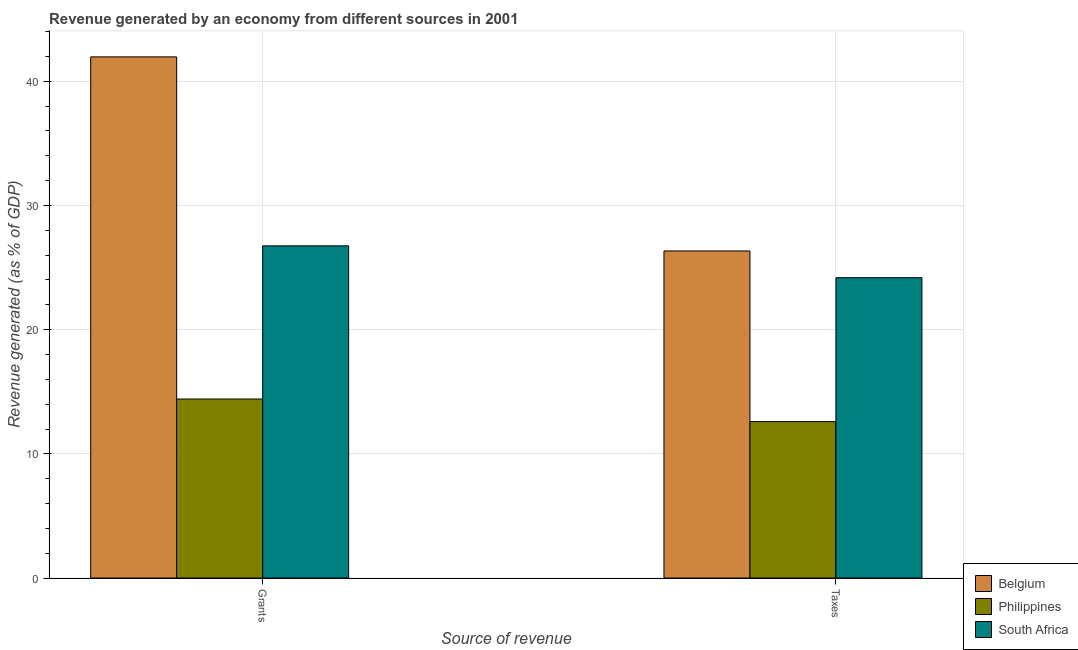How many groups of bars are there?
Provide a succinct answer. 2. Are the number of bars on each tick of the X-axis equal?
Ensure brevity in your answer.  Yes. How many bars are there on the 2nd tick from the left?
Offer a very short reply. 3. What is the label of the 1st group of bars from the left?
Make the answer very short. Grants. What is the revenue generated by grants in Belgium?
Your answer should be very brief. 41.97. Across all countries, what is the maximum revenue generated by grants?
Provide a succinct answer. 41.97. Across all countries, what is the minimum revenue generated by grants?
Ensure brevity in your answer.  14.41. In which country was the revenue generated by taxes maximum?
Offer a very short reply. Belgium. In which country was the revenue generated by grants minimum?
Provide a short and direct response. Philippines. What is the total revenue generated by grants in the graph?
Keep it short and to the point. 83.13. What is the difference between the revenue generated by grants in Philippines and that in Belgium?
Give a very brief answer. -27.55. What is the difference between the revenue generated by grants in Philippines and the revenue generated by taxes in Belgium?
Give a very brief answer. -11.92. What is the average revenue generated by taxes per country?
Your answer should be compact. 21.04. What is the difference between the revenue generated by grants and revenue generated by taxes in South Africa?
Give a very brief answer. 2.56. What is the ratio of the revenue generated by grants in South Africa to that in Belgium?
Ensure brevity in your answer.  0.64. Is the revenue generated by taxes in South Africa less than that in Belgium?
Make the answer very short. Yes. In how many countries, is the revenue generated by grants greater than the average revenue generated by grants taken over all countries?
Keep it short and to the point. 1. What does the 3rd bar from the left in Grants represents?
Offer a terse response. South Africa. What does the 3rd bar from the right in Taxes represents?
Give a very brief answer. Belgium. How many bars are there?
Your response must be concise. 6. How many countries are there in the graph?
Your answer should be very brief. 3. What is the difference between two consecutive major ticks on the Y-axis?
Give a very brief answer. 10. Does the graph contain any zero values?
Offer a very short reply. No. How many legend labels are there?
Make the answer very short. 3. How are the legend labels stacked?
Your answer should be very brief. Vertical. What is the title of the graph?
Keep it short and to the point. Revenue generated by an economy from different sources in 2001. What is the label or title of the X-axis?
Offer a very short reply. Source of revenue. What is the label or title of the Y-axis?
Ensure brevity in your answer.  Revenue generated (as % of GDP). What is the Revenue generated (as % of GDP) of Belgium in Grants?
Your answer should be compact. 41.97. What is the Revenue generated (as % of GDP) of Philippines in Grants?
Offer a very short reply. 14.41. What is the Revenue generated (as % of GDP) of South Africa in Grants?
Provide a succinct answer. 26.75. What is the Revenue generated (as % of GDP) in Belgium in Taxes?
Your answer should be very brief. 26.34. What is the Revenue generated (as % of GDP) of Philippines in Taxes?
Ensure brevity in your answer.  12.6. What is the Revenue generated (as % of GDP) of South Africa in Taxes?
Give a very brief answer. 24.19. Across all Source of revenue, what is the maximum Revenue generated (as % of GDP) of Belgium?
Offer a terse response. 41.97. Across all Source of revenue, what is the maximum Revenue generated (as % of GDP) in Philippines?
Your answer should be very brief. 14.41. Across all Source of revenue, what is the maximum Revenue generated (as % of GDP) of South Africa?
Make the answer very short. 26.75. Across all Source of revenue, what is the minimum Revenue generated (as % of GDP) of Belgium?
Ensure brevity in your answer.  26.34. Across all Source of revenue, what is the minimum Revenue generated (as % of GDP) in Philippines?
Give a very brief answer. 12.6. Across all Source of revenue, what is the minimum Revenue generated (as % of GDP) of South Africa?
Your answer should be compact. 24.19. What is the total Revenue generated (as % of GDP) in Belgium in the graph?
Offer a terse response. 68.3. What is the total Revenue generated (as % of GDP) of Philippines in the graph?
Your response must be concise. 27.01. What is the total Revenue generated (as % of GDP) in South Africa in the graph?
Provide a short and direct response. 50.94. What is the difference between the Revenue generated (as % of GDP) in Belgium in Grants and that in Taxes?
Ensure brevity in your answer.  15.63. What is the difference between the Revenue generated (as % of GDP) of Philippines in Grants and that in Taxes?
Keep it short and to the point. 1.82. What is the difference between the Revenue generated (as % of GDP) of South Africa in Grants and that in Taxes?
Your response must be concise. 2.56. What is the difference between the Revenue generated (as % of GDP) in Belgium in Grants and the Revenue generated (as % of GDP) in Philippines in Taxes?
Give a very brief answer. 29.37. What is the difference between the Revenue generated (as % of GDP) in Belgium in Grants and the Revenue generated (as % of GDP) in South Africa in Taxes?
Ensure brevity in your answer.  17.78. What is the difference between the Revenue generated (as % of GDP) of Philippines in Grants and the Revenue generated (as % of GDP) of South Africa in Taxes?
Offer a terse response. -9.77. What is the average Revenue generated (as % of GDP) of Belgium per Source of revenue?
Make the answer very short. 34.15. What is the average Revenue generated (as % of GDP) in Philippines per Source of revenue?
Provide a succinct answer. 13.51. What is the average Revenue generated (as % of GDP) of South Africa per Source of revenue?
Ensure brevity in your answer.  25.47. What is the difference between the Revenue generated (as % of GDP) in Belgium and Revenue generated (as % of GDP) in Philippines in Grants?
Make the answer very short. 27.55. What is the difference between the Revenue generated (as % of GDP) of Belgium and Revenue generated (as % of GDP) of South Africa in Grants?
Keep it short and to the point. 15.21. What is the difference between the Revenue generated (as % of GDP) in Philippines and Revenue generated (as % of GDP) in South Africa in Grants?
Give a very brief answer. -12.34. What is the difference between the Revenue generated (as % of GDP) of Belgium and Revenue generated (as % of GDP) of Philippines in Taxes?
Make the answer very short. 13.74. What is the difference between the Revenue generated (as % of GDP) in Belgium and Revenue generated (as % of GDP) in South Africa in Taxes?
Ensure brevity in your answer.  2.15. What is the difference between the Revenue generated (as % of GDP) of Philippines and Revenue generated (as % of GDP) of South Africa in Taxes?
Keep it short and to the point. -11.59. What is the ratio of the Revenue generated (as % of GDP) of Belgium in Grants to that in Taxes?
Provide a succinct answer. 1.59. What is the ratio of the Revenue generated (as % of GDP) of Philippines in Grants to that in Taxes?
Make the answer very short. 1.14. What is the ratio of the Revenue generated (as % of GDP) of South Africa in Grants to that in Taxes?
Keep it short and to the point. 1.11. What is the difference between the highest and the second highest Revenue generated (as % of GDP) in Belgium?
Offer a very short reply. 15.63. What is the difference between the highest and the second highest Revenue generated (as % of GDP) of Philippines?
Make the answer very short. 1.82. What is the difference between the highest and the second highest Revenue generated (as % of GDP) in South Africa?
Your answer should be very brief. 2.56. What is the difference between the highest and the lowest Revenue generated (as % of GDP) in Belgium?
Give a very brief answer. 15.63. What is the difference between the highest and the lowest Revenue generated (as % of GDP) of Philippines?
Your answer should be compact. 1.82. What is the difference between the highest and the lowest Revenue generated (as % of GDP) of South Africa?
Keep it short and to the point. 2.56. 